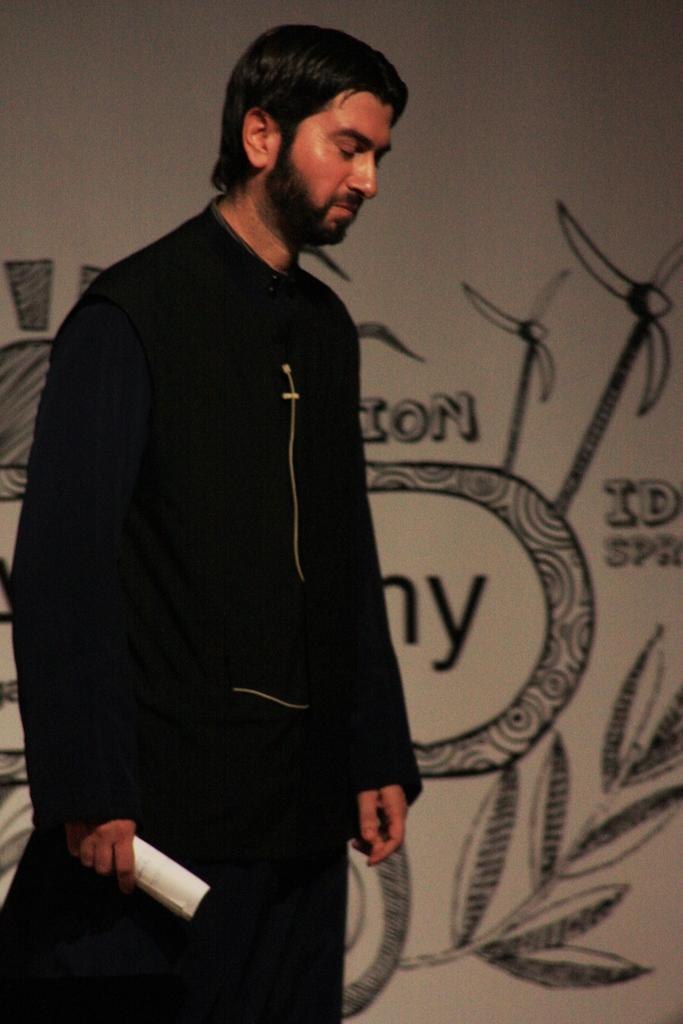Who is present in the image? There is a man in the image. What is the man wearing? The man is wearing a black dress. Where is the man positioned in the image? The man is standing in the front of the image. What is the man holding in the image? The man is holding a paper. What can be seen in the background of the image? There is a wall in the background of the image, and it has art on it. What type of lip can be seen on the man in the image? There is no lip visible on the man in the image, as he is wearing a dress and not showing any facial features. 